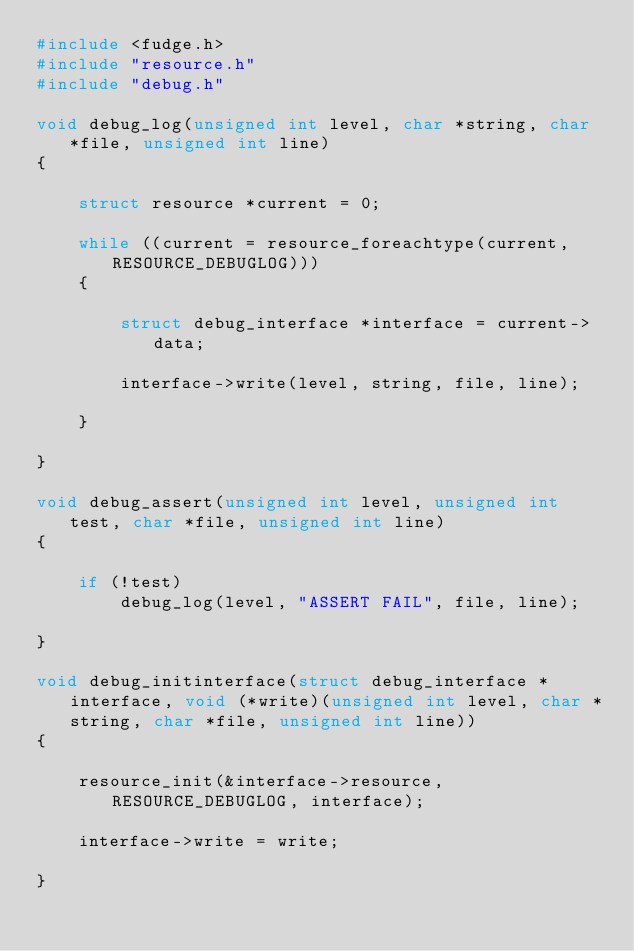Convert code to text. <code><loc_0><loc_0><loc_500><loc_500><_C_>#include <fudge.h>
#include "resource.h"
#include "debug.h"

void debug_log(unsigned int level, char *string, char *file, unsigned int line)
{

    struct resource *current = 0;

    while ((current = resource_foreachtype(current, RESOURCE_DEBUGLOG)))
    {

        struct debug_interface *interface = current->data;

        interface->write(level, string, file, line);

    }

}

void debug_assert(unsigned int level, unsigned int test, char *file, unsigned int line)
{

    if (!test)
        debug_log(level, "ASSERT FAIL", file, line);

}

void debug_initinterface(struct debug_interface *interface, void (*write)(unsigned int level, char *string, char *file, unsigned int line))
{

    resource_init(&interface->resource, RESOURCE_DEBUGLOG, interface);

    interface->write = write;

}

</code> 